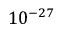Convert formula to latex. <formula><loc_0><loc_0><loc_500><loc_500>1 0 ^ { - 2 7 }</formula> 